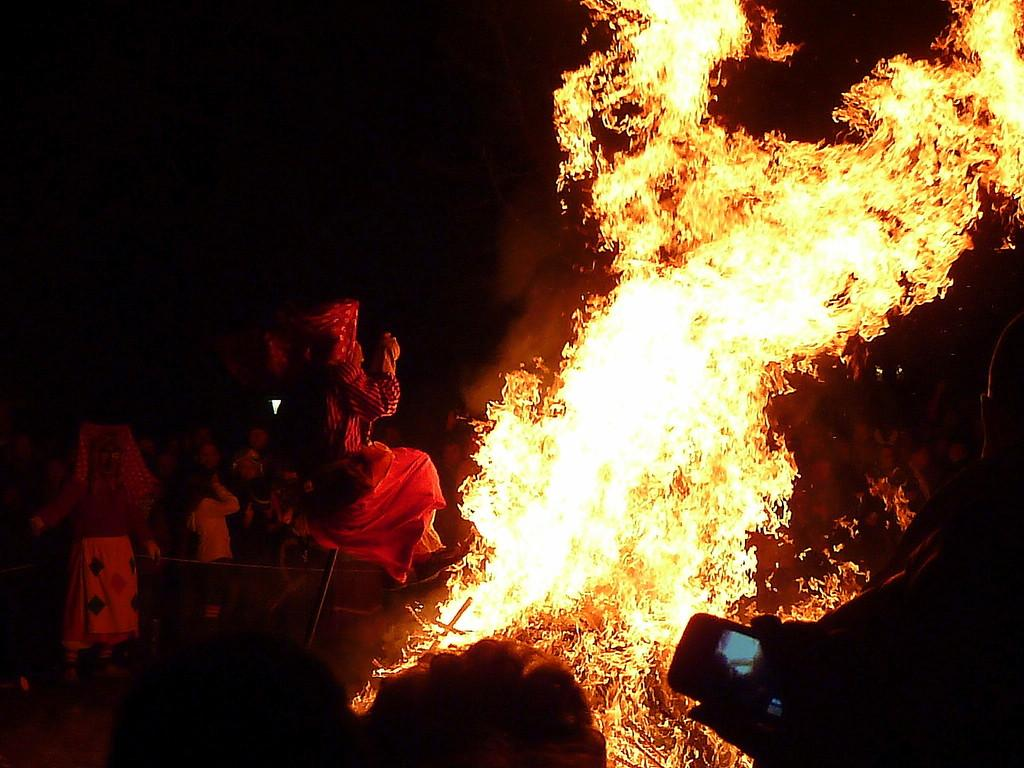Who or what can be seen in the image? There are people in the image. What is happening in the image? There is a fire in the image. What electronic device is present in the image? There is a cell phone in the image. What can be observed about the lighting in the image? The background of the image is dark. What type of boundary can be seen in the image? There is no boundary present in the image. Can you tell me the value of the pickle in the image? There is no pickle present in the image, so its value cannot be determined. 